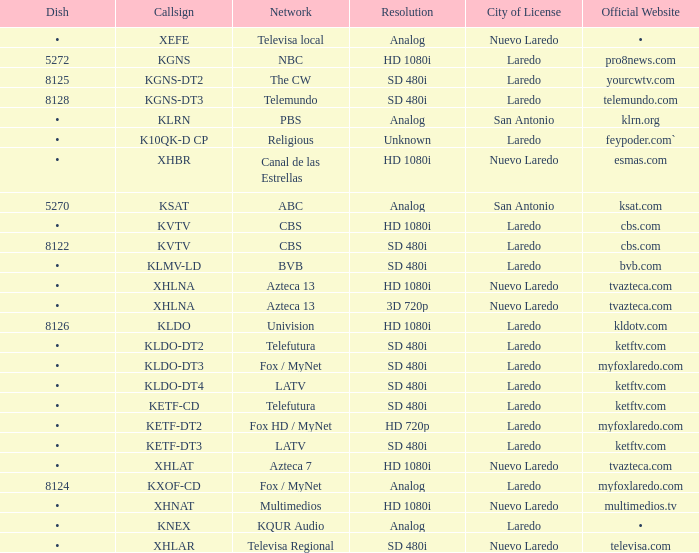Identify the resolution associated with an 8126 dish. HD 1080i. 